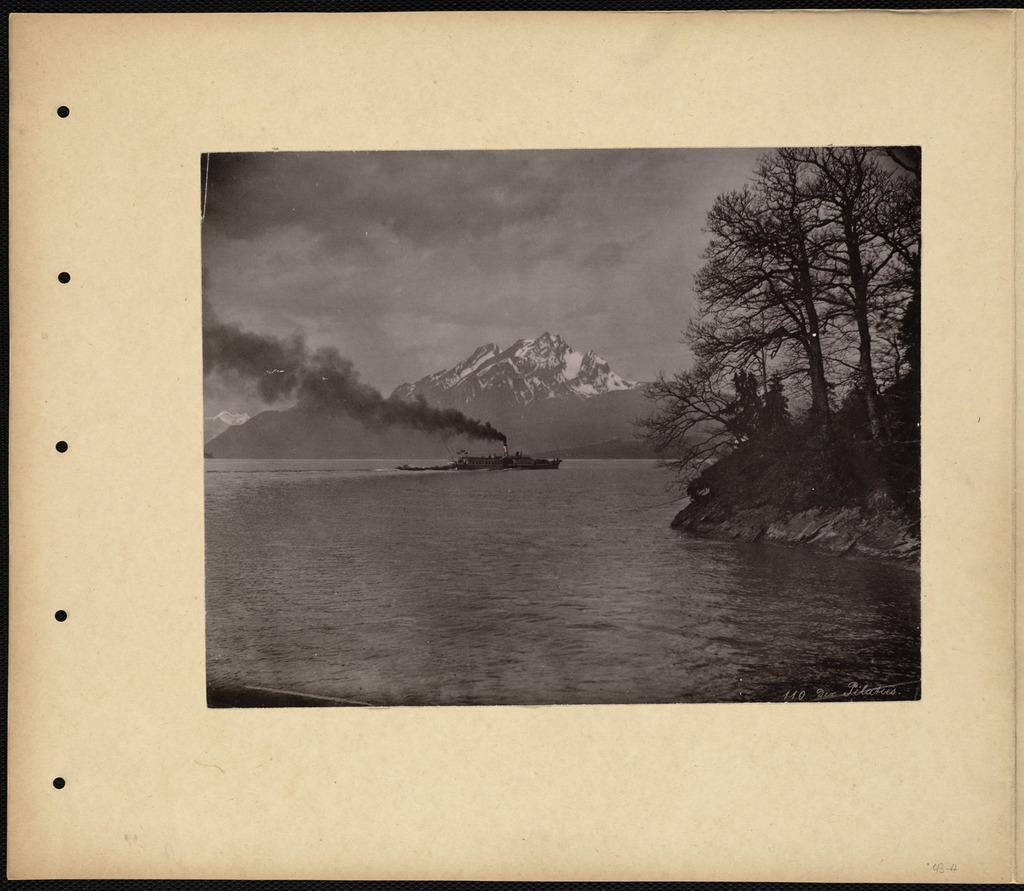What is the main subject of the image? The main subject of the image is a photo. What elements are present in the photo? The photo contains water, trees, hills, and the sky. What is the condition of the sky in the photo? The sky is visible in the background of the photo, and clouds are present. What type of wire can be seen connecting the trees in the photo? There is no wire present in the photo; it only contains water, trees, hills, and the sky. 